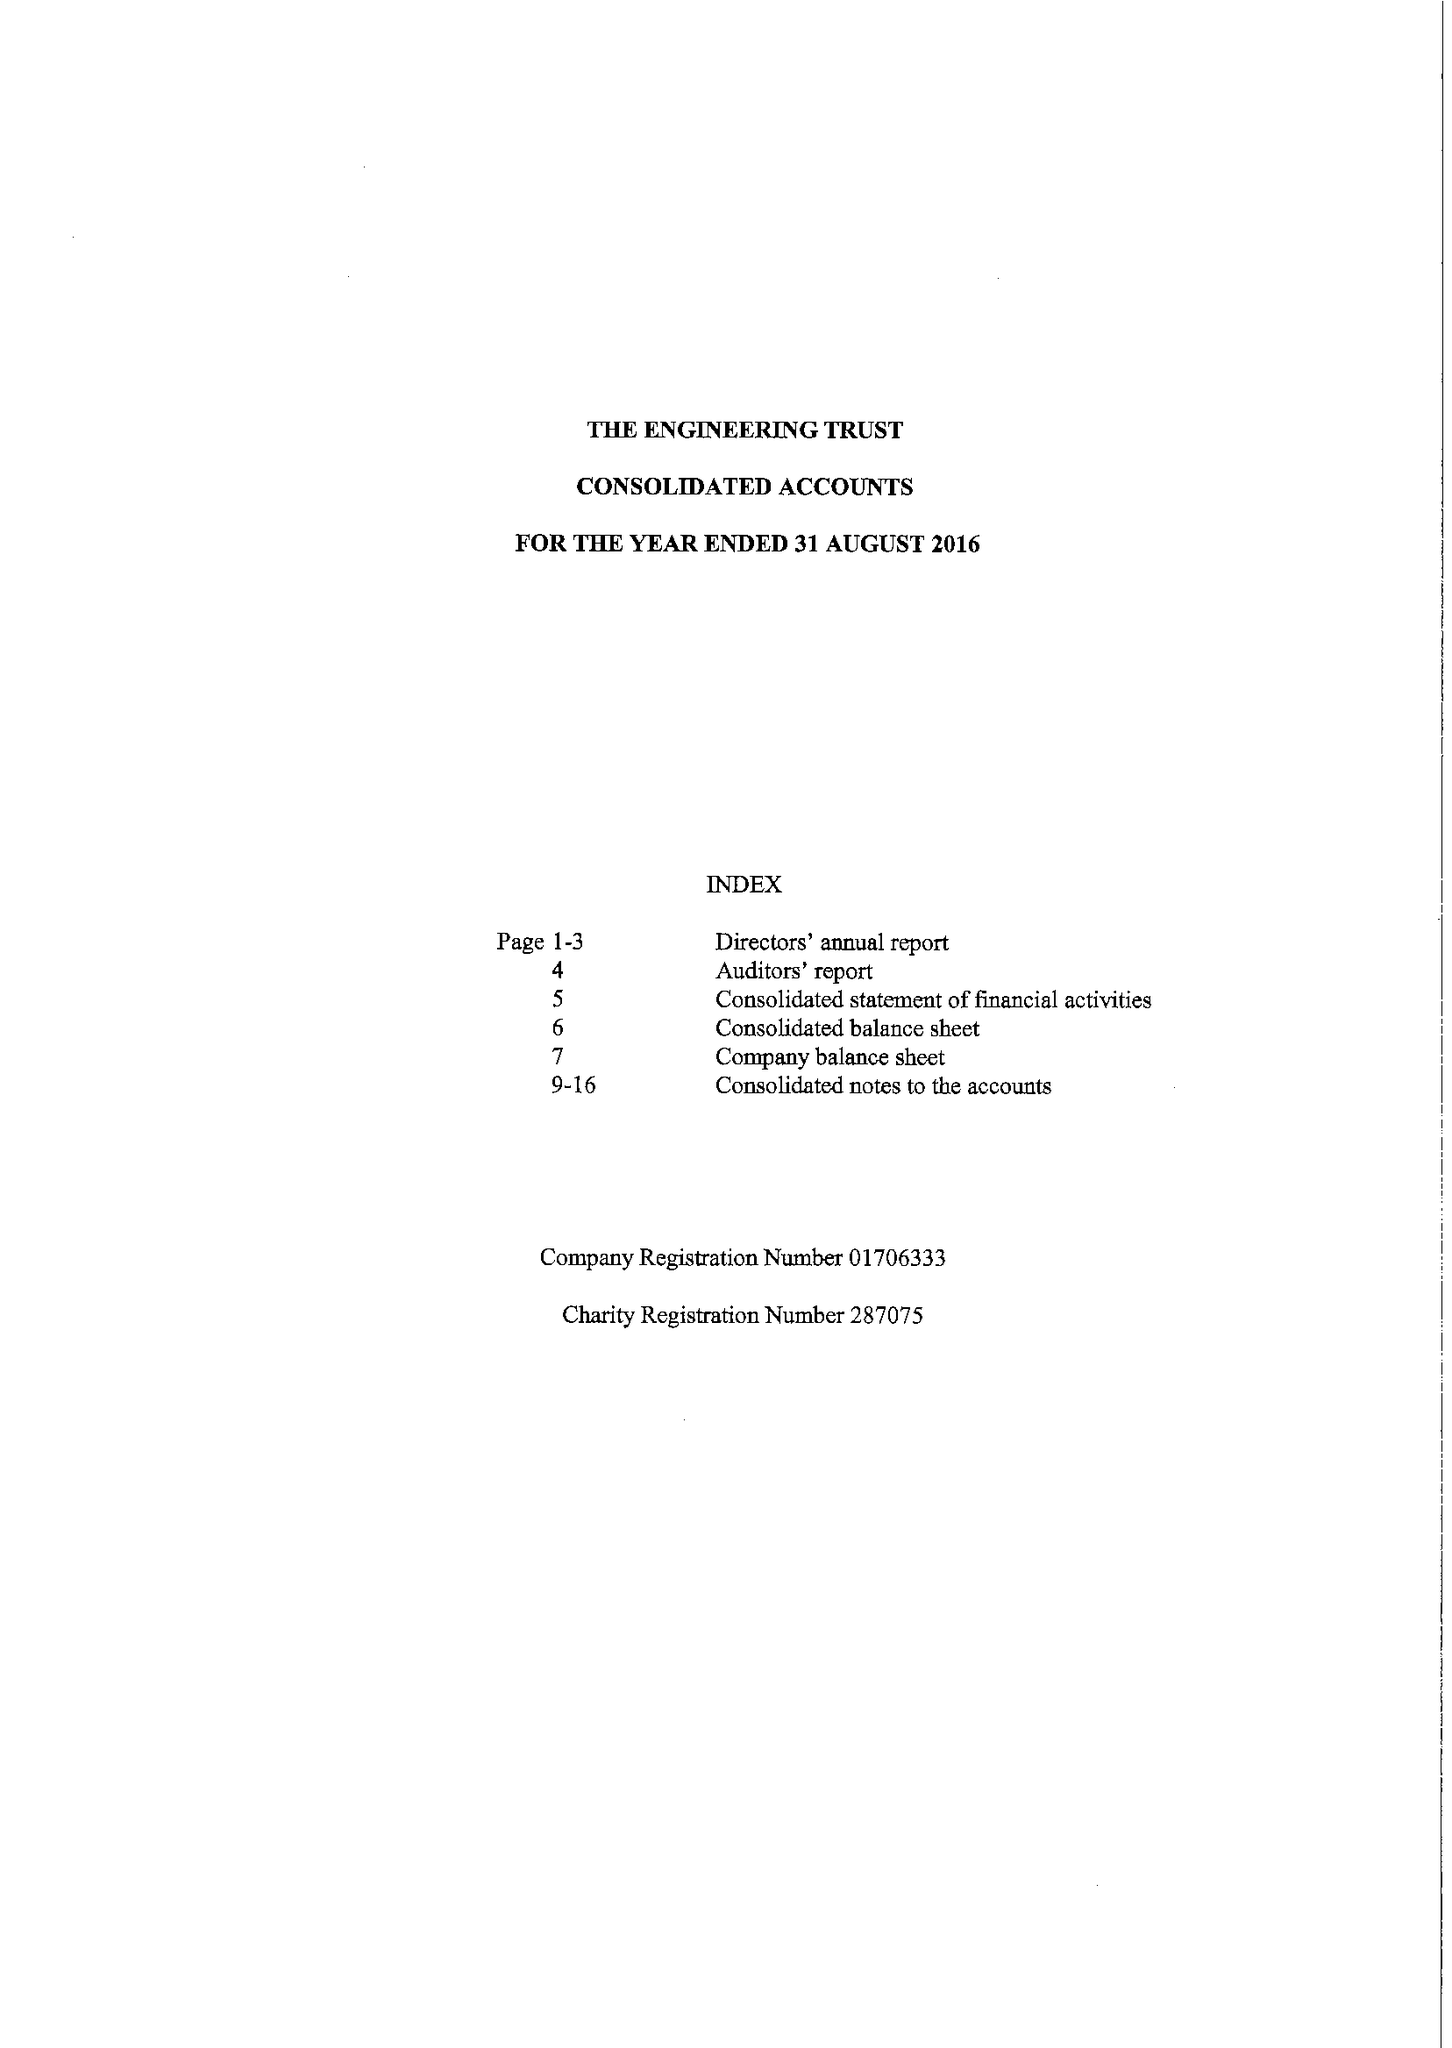What is the value for the charity_name?
Answer the question using a single word or phrase. The Engineering Trust 